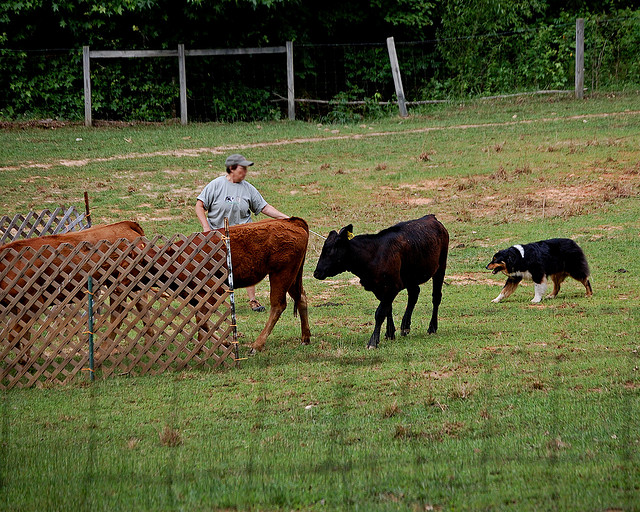<image>What breed of dog is in this photograph? I don't know the exact breed of the dog in the photograph. It could be a shepherd, sheepdog, collie, or bernese mountain dog. What breed of dog is in this photograph? I am not sure what breed of dog is in the photograph. It can be seen as 'shepherd', 'sheepdog', 'sheep hound', 'collie' or 'bernese mountain'. 